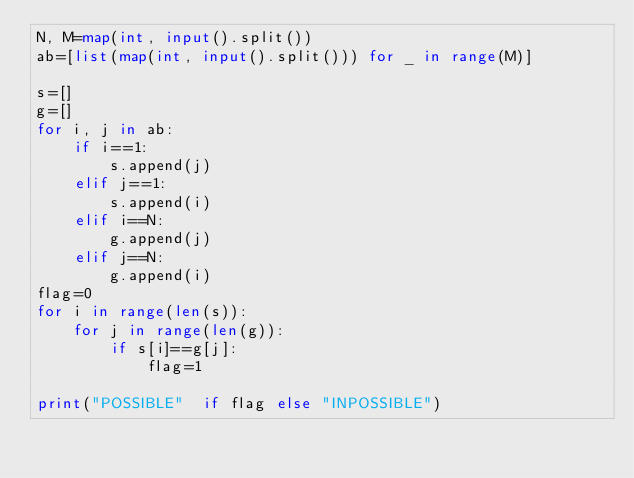<code> <loc_0><loc_0><loc_500><loc_500><_Python_>N, M=map(int, input().split())
ab=[list(map(int, input().split())) for _ in range(M)]

s=[]
g=[]
for i, j in ab:
    if i==1:
        s.append(j)
    elif j==1:
        s.append(i)
    elif i==N:
        g.append(j)
    elif j==N:
        g.append(i)
flag=0
for i in range(len(s)):
    for j in range(len(g)):
        if s[i]==g[j]:
            flag=1

print("POSSIBLE"  if flag else "INPOSSIBLE")
</code> 